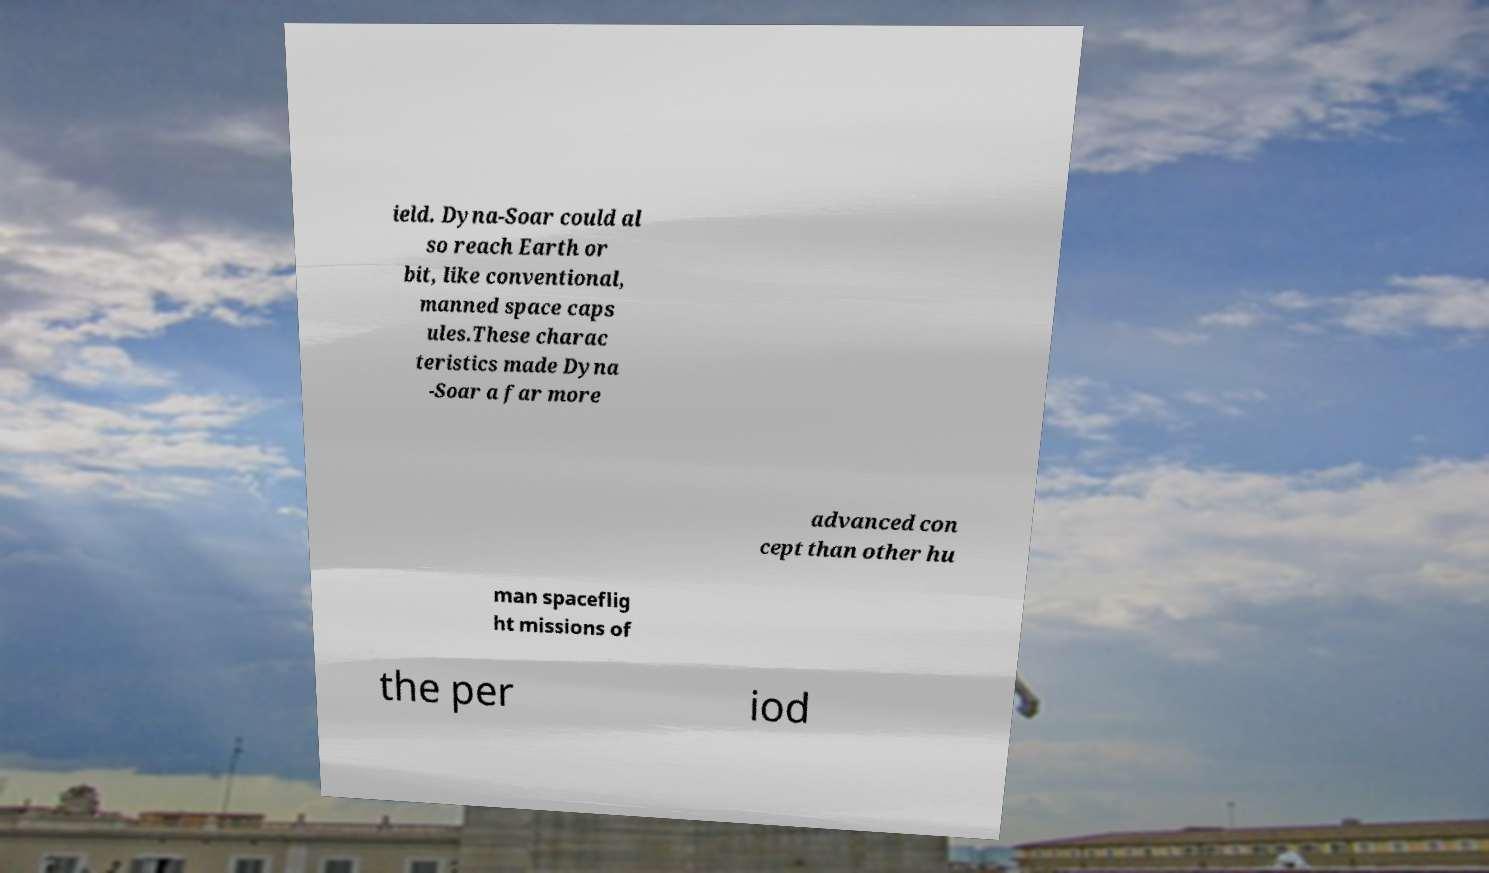Could you extract and type out the text from this image? ield. Dyna-Soar could al so reach Earth or bit, like conventional, manned space caps ules.These charac teristics made Dyna -Soar a far more advanced con cept than other hu man spaceflig ht missions of the per iod 